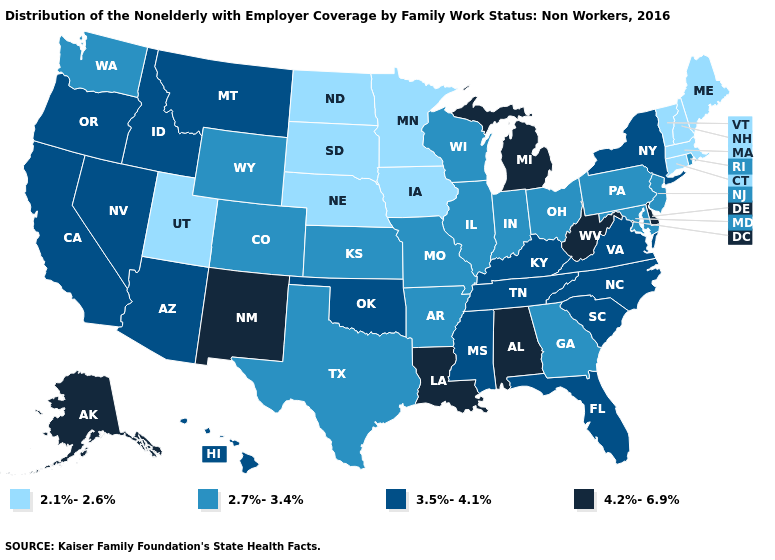Name the states that have a value in the range 2.1%-2.6%?
Be succinct. Connecticut, Iowa, Maine, Massachusetts, Minnesota, Nebraska, New Hampshire, North Dakota, South Dakota, Utah, Vermont. Does North Carolina have the highest value in the South?
Quick response, please. No. Name the states that have a value in the range 2.1%-2.6%?
Concise answer only. Connecticut, Iowa, Maine, Massachusetts, Minnesota, Nebraska, New Hampshire, North Dakota, South Dakota, Utah, Vermont. What is the value of Mississippi?
Keep it brief. 3.5%-4.1%. Is the legend a continuous bar?
Concise answer only. No. What is the lowest value in states that border Oklahoma?
Answer briefly. 2.7%-3.4%. Name the states that have a value in the range 4.2%-6.9%?
Short answer required. Alabama, Alaska, Delaware, Louisiana, Michigan, New Mexico, West Virginia. What is the value of Kentucky?
Keep it brief. 3.5%-4.1%. Name the states that have a value in the range 2.7%-3.4%?
Be succinct. Arkansas, Colorado, Georgia, Illinois, Indiana, Kansas, Maryland, Missouri, New Jersey, Ohio, Pennsylvania, Rhode Island, Texas, Washington, Wisconsin, Wyoming. Which states have the highest value in the USA?
Concise answer only. Alabama, Alaska, Delaware, Louisiana, Michigan, New Mexico, West Virginia. What is the lowest value in the USA?
Short answer required. 2.1%-2.6%. What is the value of Louisiana?
Be succinct. 4.2%-6.9%. What is the value of Arizona?
Be succinct. 3.5%-4.1%. Name the states that have a value in the range 3.5%-4.1%?
Quick response, please. Arizona, California, Florida, Hawaii, Idaho, Kentucky, Mississippi, Montana, Nevada, New York, North Carolina, Oklahoma, Oregon, South Carolina, Tennessee, Virginia. What is the value of Oklahoma?
Short answer required. 3.5%-4.1%. 